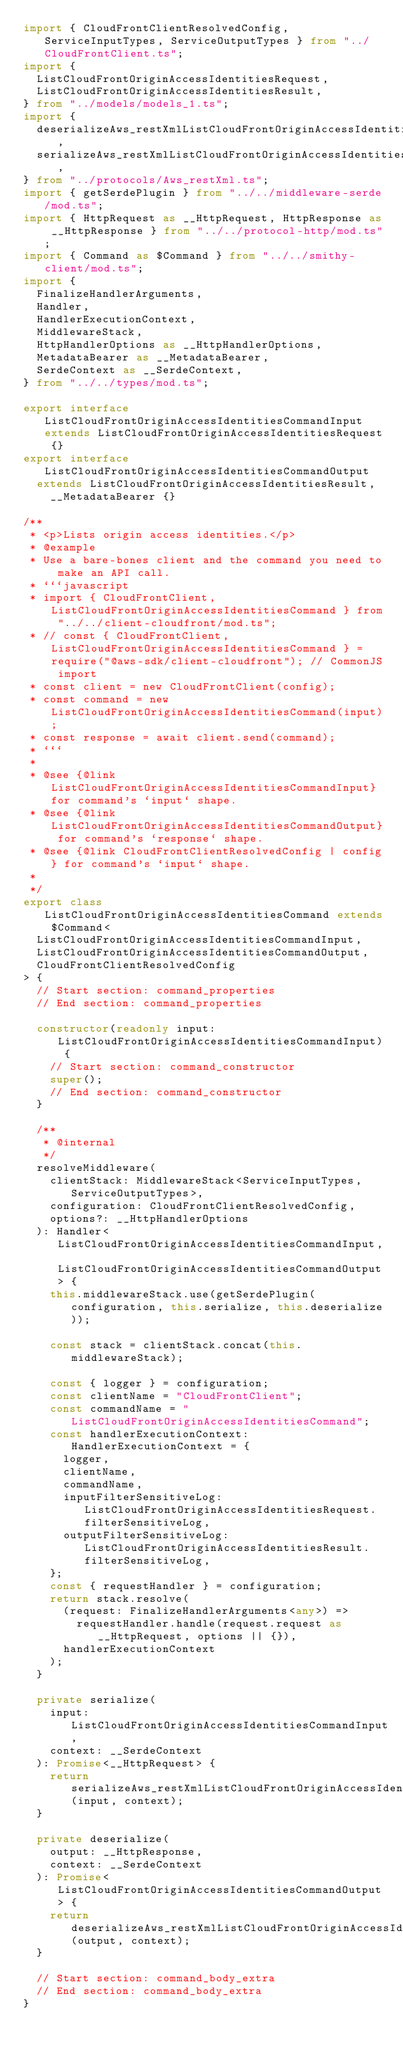<code> <loc_0><loc_0><loc_500><loc_500><_TypeScript_>import { CloudFrontClientResolvedConfig, ServiceInputTypes, ServiceOutputTypes } from "../CloudFrontClient.ts";
import {
  ListCloudFrontOriginAccessIdentitiesRequest,
  ListCloudFrontOriginAccessIdentitiesResult,
} from "../models/models_1.ts";
import {
  deserializeAws_restXmlListCloudFrontOriginAccessIdentitiesCommand,
  serializeAws_restXmlListCloudFrontOriginAccessIdentitiesCommand,
} from "../protocols/Aws_restXml.ts";
import { getSerdePlugin } from "../../middleware-serde/mod.ts";
import { HttpRequest as __HttpRequest, HttpResponse as __HttpResponse } from "../../protocol-http/mod.ts";
import { Command as $Command } from "../../smithy-client/mod.ts";
import {
  FinalizeHandlerArguments,
  Handler,
  HandlerExecutionContext,
  MiddlewareStack,
  HttpHandlerOptions as __HttpHandlerOptions,
  MetadataBearer as __MetadataBearer,
  SerdeContext as __SerdeContext,
} from "../../types/mod.ts";

export interface ListCloudFrontOriginAccessIdentitiesCommandInput extends ListCloudFrontOriginAccessIdentitiesRequest {}
export interface ListCloudFrontOriginAccessIdentitiesCommandOutput
  extends ListCloudFrontOriginAccessIdentitiesResult,
    __MetadataBearer {}

/**
 * <p>Lists origin access identities.</p>
 * @example
 * Use a bare-bones client and the command you need to make an API call.
 * ```javascript
 * import { CloudFrontClient, ListCloudFrontOriginAccessIdentitiesCommand } from "../../client-cloudfront/mod.ts";
 * // const { CloudFrontClient, ListCloudFrontOriginAccessIdentitiesCommand } = require("@aws-sdk/client-cloudfront"); // CommonJS import
 * const client = new CloudFrontClient(config);
 * const command = new ListCloudFrontOriginAccessIdentitiesCommand(input);
 * const response = await client.send(command);
 * ```
 *
 * @see {@link ListCloudFrontOriginAccessIdentitiesCommandInput} for command's `input` shape.
 * @see {@link ListCloudFrontOriginAccessIdentitiesCommandOutput} for command's `response` shape.
 * @see {@link CloudFrontClientResolvedConfig | config} for command's `input` shape.
 *
 */
export class ListCloudFrontOriginAccessIdentitiesCommand extends $Command<
  ListCloudFrontOriginAccessIdentitiesCommandInput,
  ListCloudFrontOriginAccessIdentitiesCommandOutput,
  CloudFrontClientResolvedConfig
> {
  // Start section: command_properties
  // End section: command_properties

  constructor(readonly input: ListCloudFrontOriginAccessIdentitiesCommandInput) {
    // Start section: command_constructor
    super();
    // End section: command_constructor
  }

  /**
   * @internal
   */
  resolveMiddleware(
    clientStack: MiddlewareStack<ServiceInputTypes, ServiceOutputTypes>,
    configuration: CloudFrontClientResolvedConfig,
    options?: __HttpHandlerOptions
  ): Handler<ListCloudFrontOriginAccessIdentitiesCommandInput, ListCloudFrontOriginAccessIdentitiesCommandOutput> {
    this.middlewareStack.use(getSerdePlugin(configuration, this.serialize, this.deserialize));

    const stack = clientStack.concat(this.middlewareStack);

    const { logger } = configuration;
    const clientName = "CloudFrontClient";
    const commandName = "ListCloudFrontOriginAccessIdentitiesCommand";
    const handlerExecutionContext: HandlerExecutionContext = {
      logger,
      clientName,
      commandName,
      inputFilterSensitiveLog: ListCloudFrontOriginAccessIdentitiesRequest.filterSensitiveLog,
      outputFilterSensitiveLog: ListCloudFrontOriginAccessIdentitiesResult.filterSensitiveLog,
    };
    const { requestHandler } = configuration;
    return stack.resolve(
      (request: FinalizeHandlerArguments<any>) =>
        requestHandler.handle(request.request as __HttpRequest, options || {}),
      handlerExecutionContext
    );
  }

  private serialize(
    input: ListCloudFrontOriginAccessIdentitiesCommandInput,
    context: __SerdeContext
  ): Promise<__HttpRequest> {
    return serializeAws_restXmlListCloudFrontOriginAccessIdentitiesCommand(input, context);
  }

  private deserialize(
    output: __HttpResponse,
    context: __SerdeContext
  ): Promise<ListCloudFrontOriginAccessIdentitiesCommandOutput> {
    return deserializeAws_restXmlListCloudFrontOriginAccessIdentitiesCommand(output, context);
  }

  // Start section: command_body_extra
  // End section: command_body_extra
}
</code> 